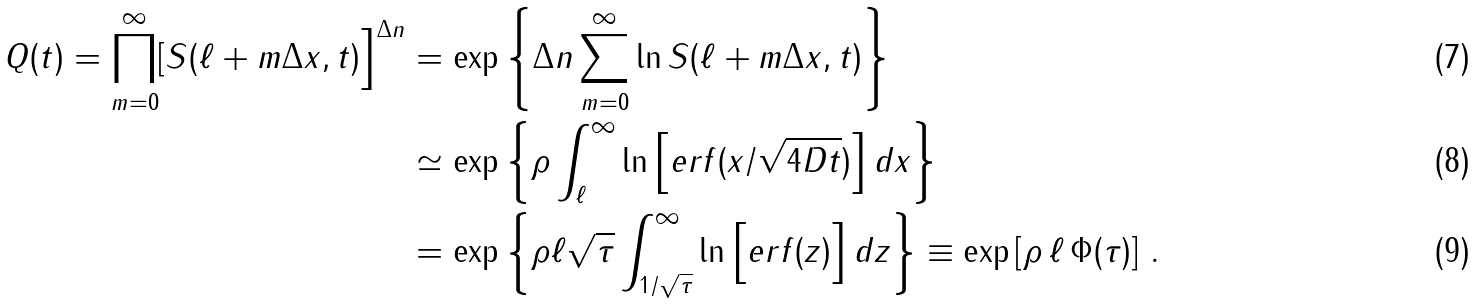Convert formula to latex. <formula><loc_0><loc_0><loc_500><loc_500>Q ( t ) = \prod _ { m = 0 } ^ { \infty } [ S ( \ell + m \Delta x , t ) \Big ] ^ { \Delta n } & = \exp \left \{ \Delta n \sum _ { m = 0 } ^ { \infty } \ln S ( \ell + m \Delta x , t ) \right \} \\ & \simeq \exp \left \{ \rho \int _ { \ell } ^ { \infty } \ln \Big [ e r f ( x / \sqrt { 4 D t } ) \Big ] \, d x \right \} \\ & = \exp \left \{ \rho \ell \sqrt { \tau } \int _ { 1 / \sqrt { \tau } } ^ { \infty } \ln \Big [ e r f ( z ) \Big ] \, d z \right \} \equiv \exp \left [ \rho \, \ell \, \Phi ( \tau ) \right ] \, .</formula> 